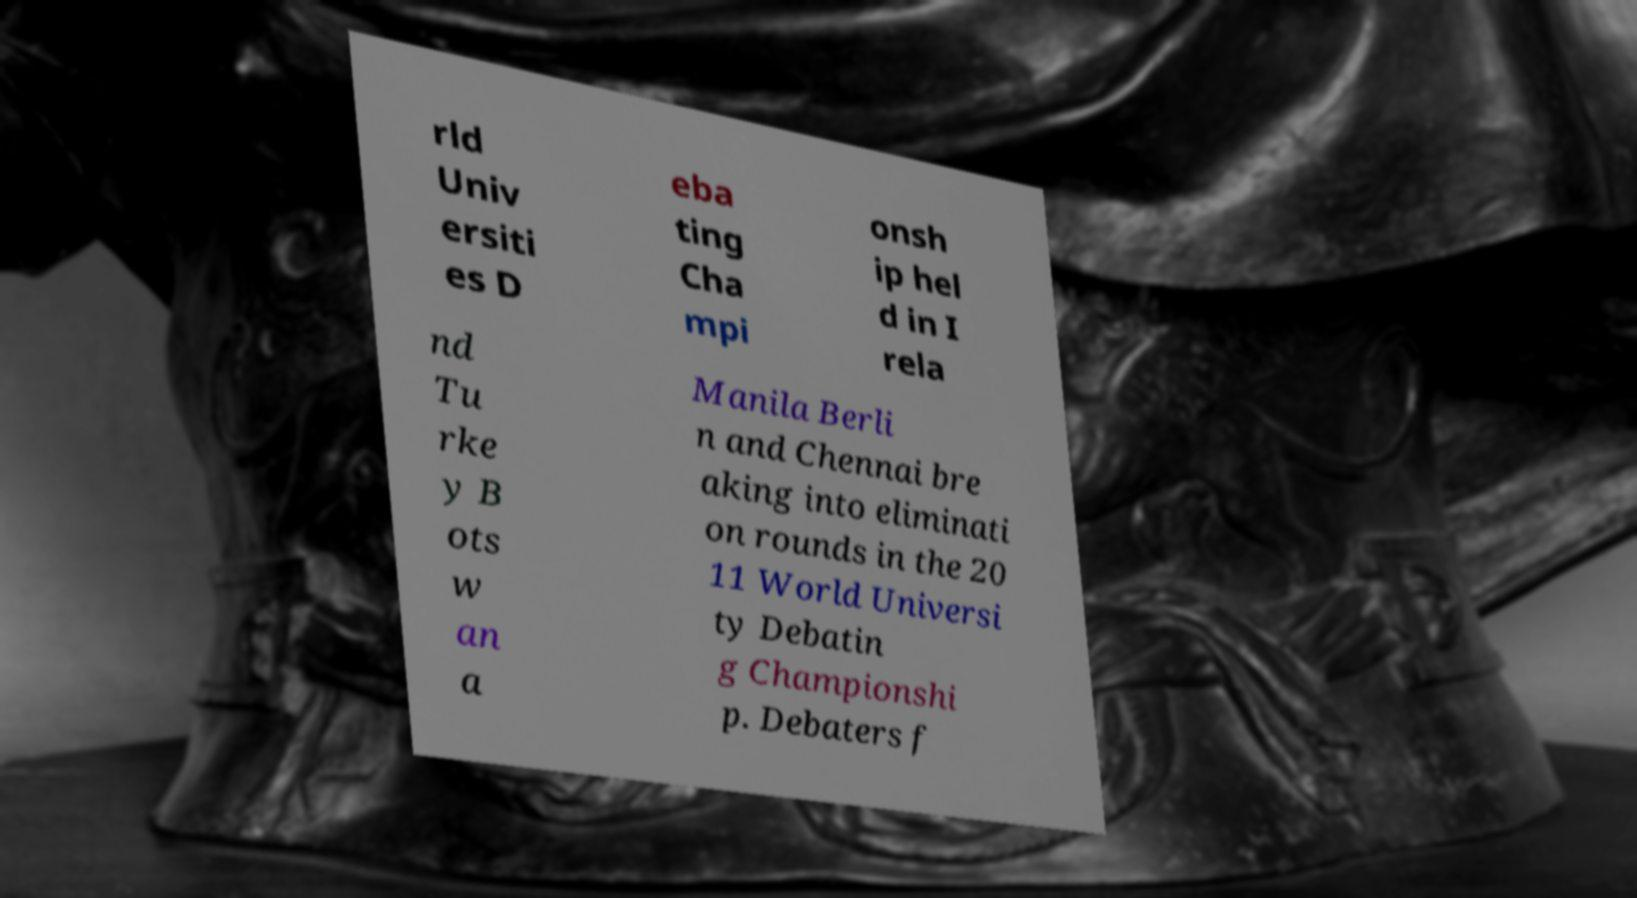For documentation purposes, I need the text within this image transcribed. Could you provide that? rld Univ ersiti es D eba ting Cha mpi onsh ip hel d in I rela nd Tu rke y B ots w an a Manila Berli n and Chennai bre aking into eliminati on rounds in the 20 11 World Universi ty Debatin g Championshi p. Debaters f 